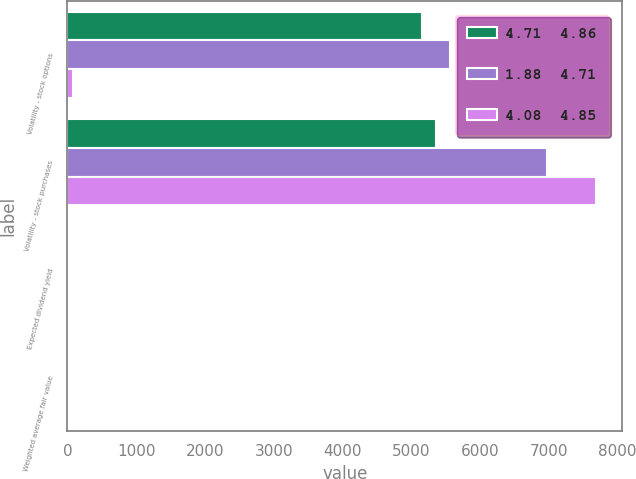Convert chart to OTSL. <chart><loc_0><loc_0><loc_500><loc_500><stacked_bar_chart><ecel><fcel>Volatility - stock options<fcel>Volatility - stock purchases<fcel>Expected dividend yield<fcel>Weighted average fair value<nl><fcel>4.71  4.86<fcel>5165<fcel>5369<fcel>0<fcel>11.45<nl><fcel>1.88  4.71<fcel>5570<fcel>6976<fcel>0<fcel>7.33<nl><fcel>4.08  4.85<fcel>76<fcel>7690<fcel>0<fcel>2.38<nl></chart> 